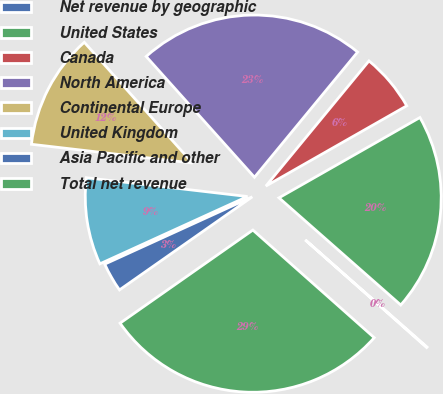Convert chart. <chart><loc_0><loc_0><loc_500><loc_500><pie_chart><fcel>Net revenue by geographic<fcel>United States<fcel>Canada<fcel>North America<fcel>Continental Europe<fcel>United Kingdom<fcel>Asia Pacific and other<fcel>Total net revenue<nl><fcel>0.06%<fcel>19.73%<fcel>5.79%<fcel>22.6%<fcel>11.52%<fcel>8.66%<fcel>2.92%<fcel>28.72%<nl></chart> 